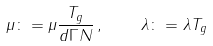Convert formula to latex. <formula><loc_0><loc_0><loc_500><loc_500>\mu \colon = \mu \frac { T _ { g } } { d \Gamma N } \, , \quad \lambda \colon = \lambda T _ { g }</formula> 